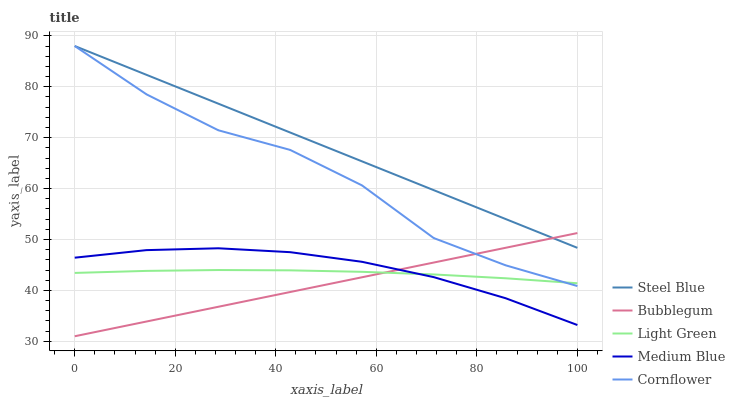Does Bubblegum have the minimum area under the curve?
Answer yes or no. Yes. Does Steel Blue have the maximum area under the curve?
Answer yes or no. Yes. Does Light Green have the minimum area under the curve?
Answer yes or no. No. Does Light Green have the maximum area under the curve?
Answer yes or no. No. Is Bubblegum the smoothest?
Answer yes or no. Yes. Is Cornflower the roughest?
Answer yes or no. Yes. Is Light Green the smoothest?
Answer yes or no. No. Is Light Green the roughest?
Answer yes or no. No. Does Light Green have the lowest value?
Answer yes or no. No. Does Steel Blue have the highest value?
Answer yes or no. Yes. Does Medium Blue have the highest value?
Answer yes or no. No. Is Light Green less than Steel Blue?
Answer yes or no. Yes. Is Steel Blue greater than Medium Blue?
Answer yes or no. Yes. Does Steel Blue intersect Bubblegum?
Answer yes or no. Yes. Is Steel Blue less than Bubblegum?
Answer yes or no. No. Is Steel Blue greater than Bubblegum?
Answer yes or no. No. Does Light Green intersect Steel Blue?
Answer yes or no. No. 